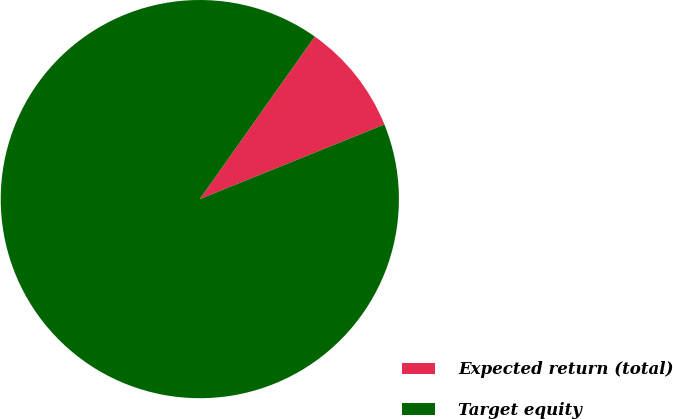Convert chart. <chart><loc_0><loc_0><loc_500><loc_500><pie_chart><fcel>Expected return (total)<fcel>Target equity<nl><fcel>9.09%<fcel>90.91%<nl></chart> 